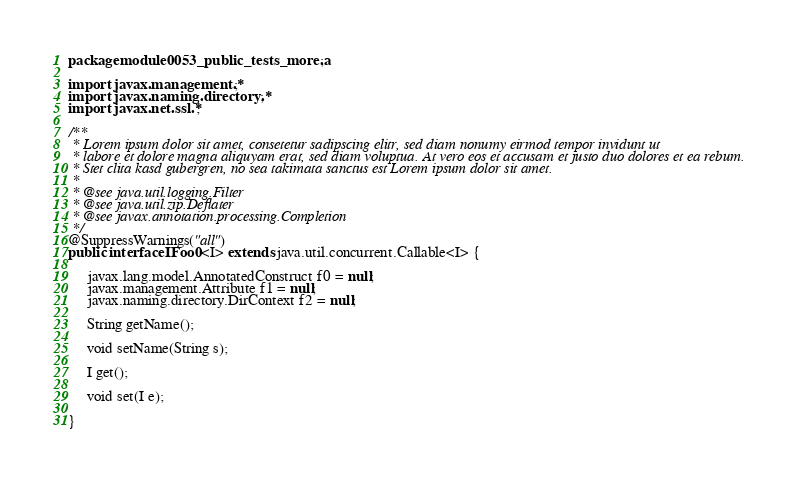Convert code to text. <code><loc_0><loc_0><loc_500><loc_500><_Java_>package module0053_public_tests_more.a;

import javax.management.*;
import javax.naming.directory.*;
import javax.net.ssl.*;

/**
 * Lorem ipsum dolor sit amet, consetetur sadipscing elitr, sed diam nonumy eirmod tempor invidunt ut 
 * labore et dolore magna aliquyam erat, sed diam voluptua. At vero eos et accusam et justo duo dolores et ea rebum. 
 * Stet clita kasd gubergren, no sea takimata sanctus est Lorem ipsum dolor sit amet. 
 *
 * @see java.util.logging.Filter
 * @see java.util.zip.Deflater
 * @see javax.annotation.processing.Completion
 */
@SuppressWarnings("all")
public interface IFoo0<I> extends java.util.concurrent.Callable<I> {

	 javax.lang.model.AnnotatedConstruct f0 = null;
	 javax.management.Attribute f1 = null;
	 javax.naming.directory.DirContext f2 = null;

	 String getName();

	 void setName(String s);

	 I get();

	 void set(I e);

}
</code> 